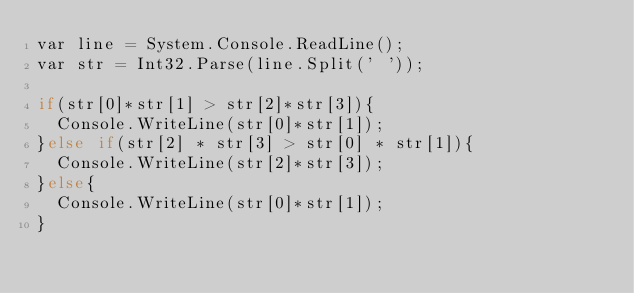Convert code to text. <code><loc_0><loc_0><loc_500><loc_500><_C#_>var line = System.Console.ReadLine();
var str = Int32.Parse(line.Split(' '));
  
if(str[0]*str[1] > str[2]*str[3]){
  Console.WriteLine(str[0]*str[1]);
}else if(str[2] * str[3] > str[0] * str[1]){
  Console.WriteLine(str[2]*str[3]);
}else{
  Console.WriteLine(str[0]*str[1]);
}
  
  </code> 